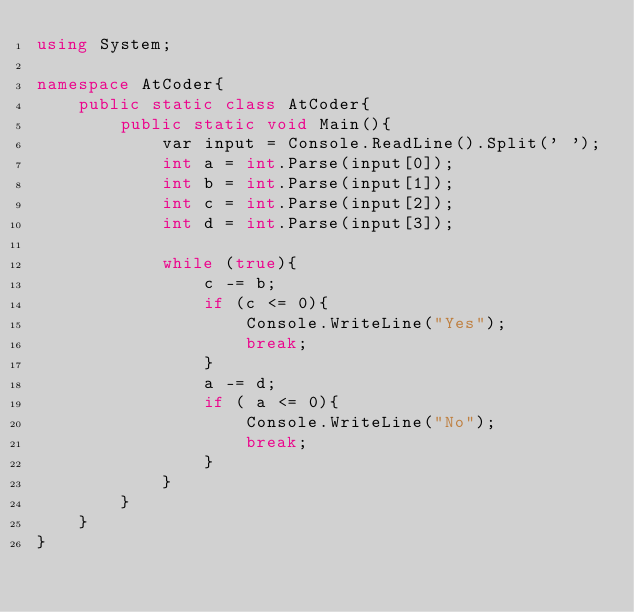Convert code to text. <code><loc_0><loc_0><loc_500><loc_500><_C#_>using System;

namespace AtCoder{
    public static class AtCoder{
        public static void Main(){
            var input = Console.ReadLine().Split(' ');
            int a = int.Parse(input[0]);
            int b = int.Parse(input[1]);
            int c = int.Parse(input[2]);
            int d = int.Parse(input[3]);

            while (true){
                c -= b;
                if (c <= 0){
                    Console.WriteLine("Yes");
                    break;
                }
                a -= d;
                if ( a <= 0){
                    Console.WriteLine("No");
                    break;
                }
            }
        }
    }
}</code> 